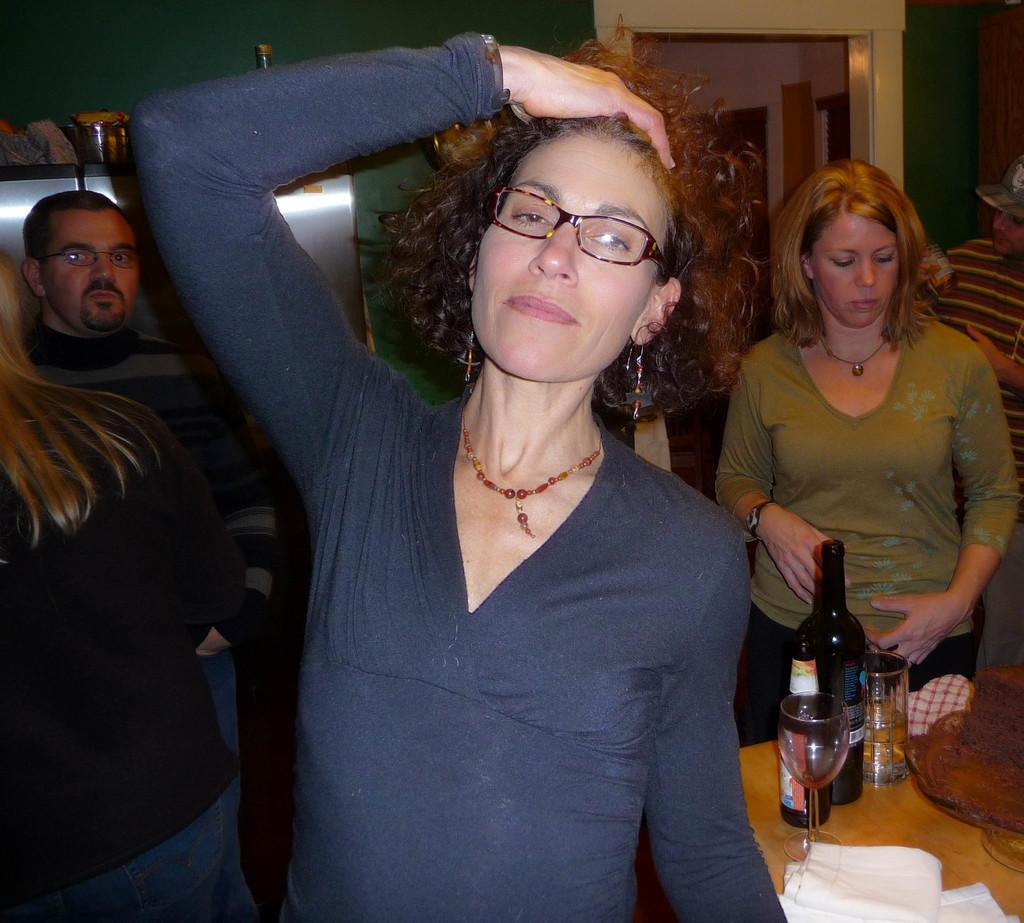What is the main subject of the image? There is a woman standing in the image. Can you describe the surroundings of the woman? There are other people standing in the background of the image, and there is a table with wine bottles and glasses on it. What is the setting of the image? There is a wall visible in the background of the image, suggesting an indoor setting. What type of cracker is being used to light the lamp in the image? There is no lamp or cracker present in the image. 